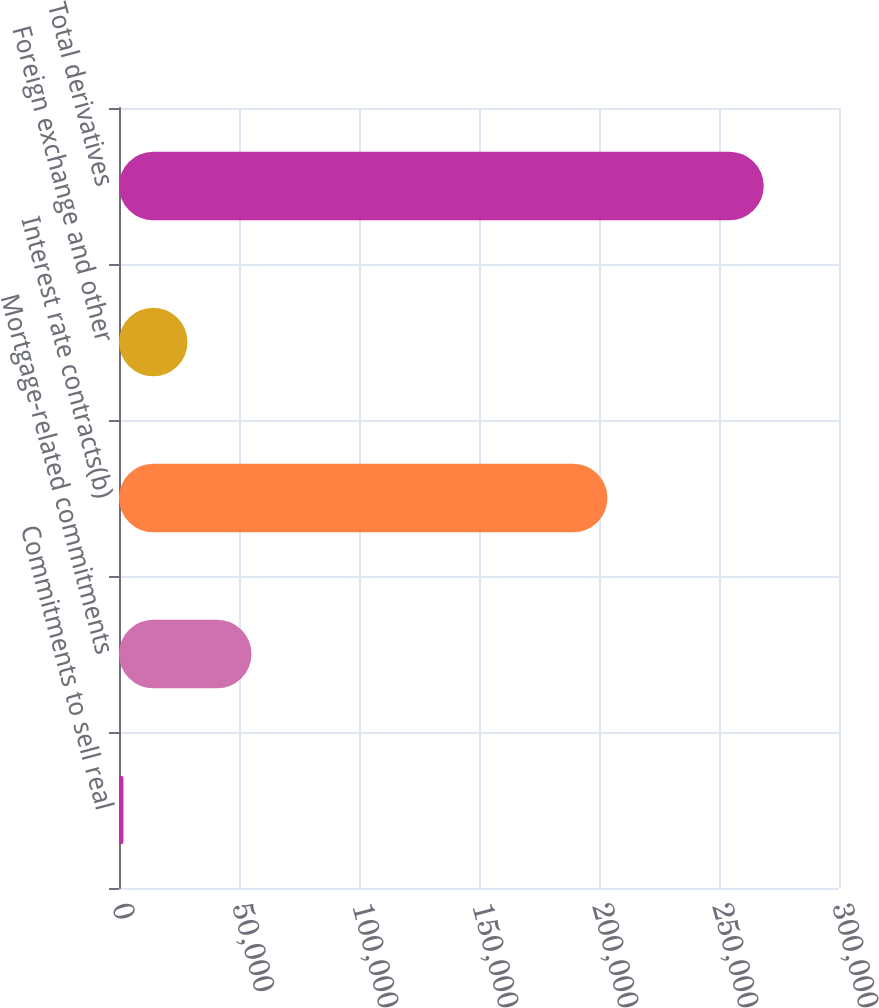Convert chart to OTSL. <chart><loc_0><loc_0><loc_500><loc_500><bar_chart><fcel>Commitments to sell real<fcel>Mortgage-related commitments<fcel>Interest rate contracts(b)<fcel>Foreign exchange and other<fcel>Total derivatives<nl><fcel>1844<fcel>55202.6<fcel>203517<fcel>28523.3<fcel>268637<nl></chart> 